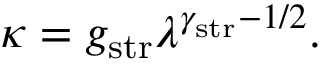Convert formula to latex. <formula><loc_0><loc_0><loc_500><loc_500>\kappa = g _ { s t r } \lambda ^ { \gamma _ { s t r } - 1 / 2 } .</formula> 